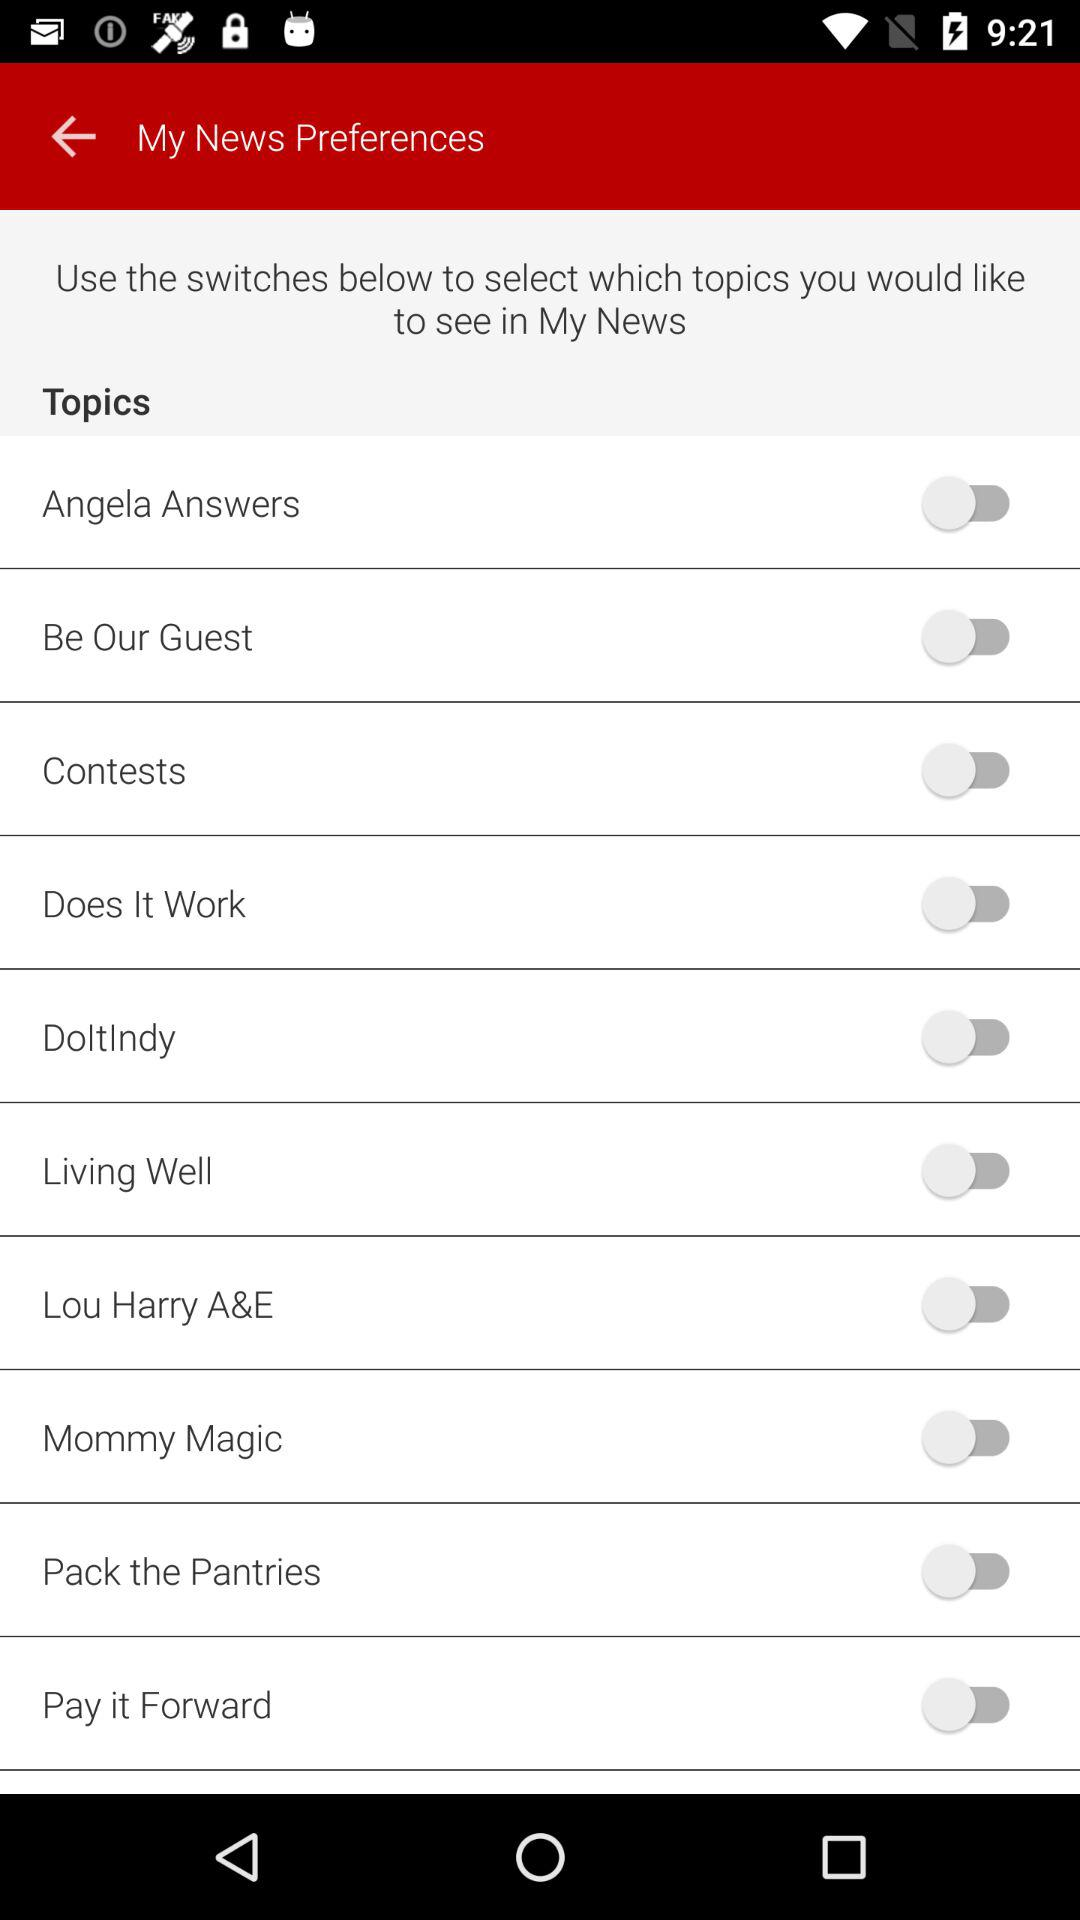What is the status of "My News Preferences"?
When the provided information is insufficient, respond with <no answer>. <no answer> 